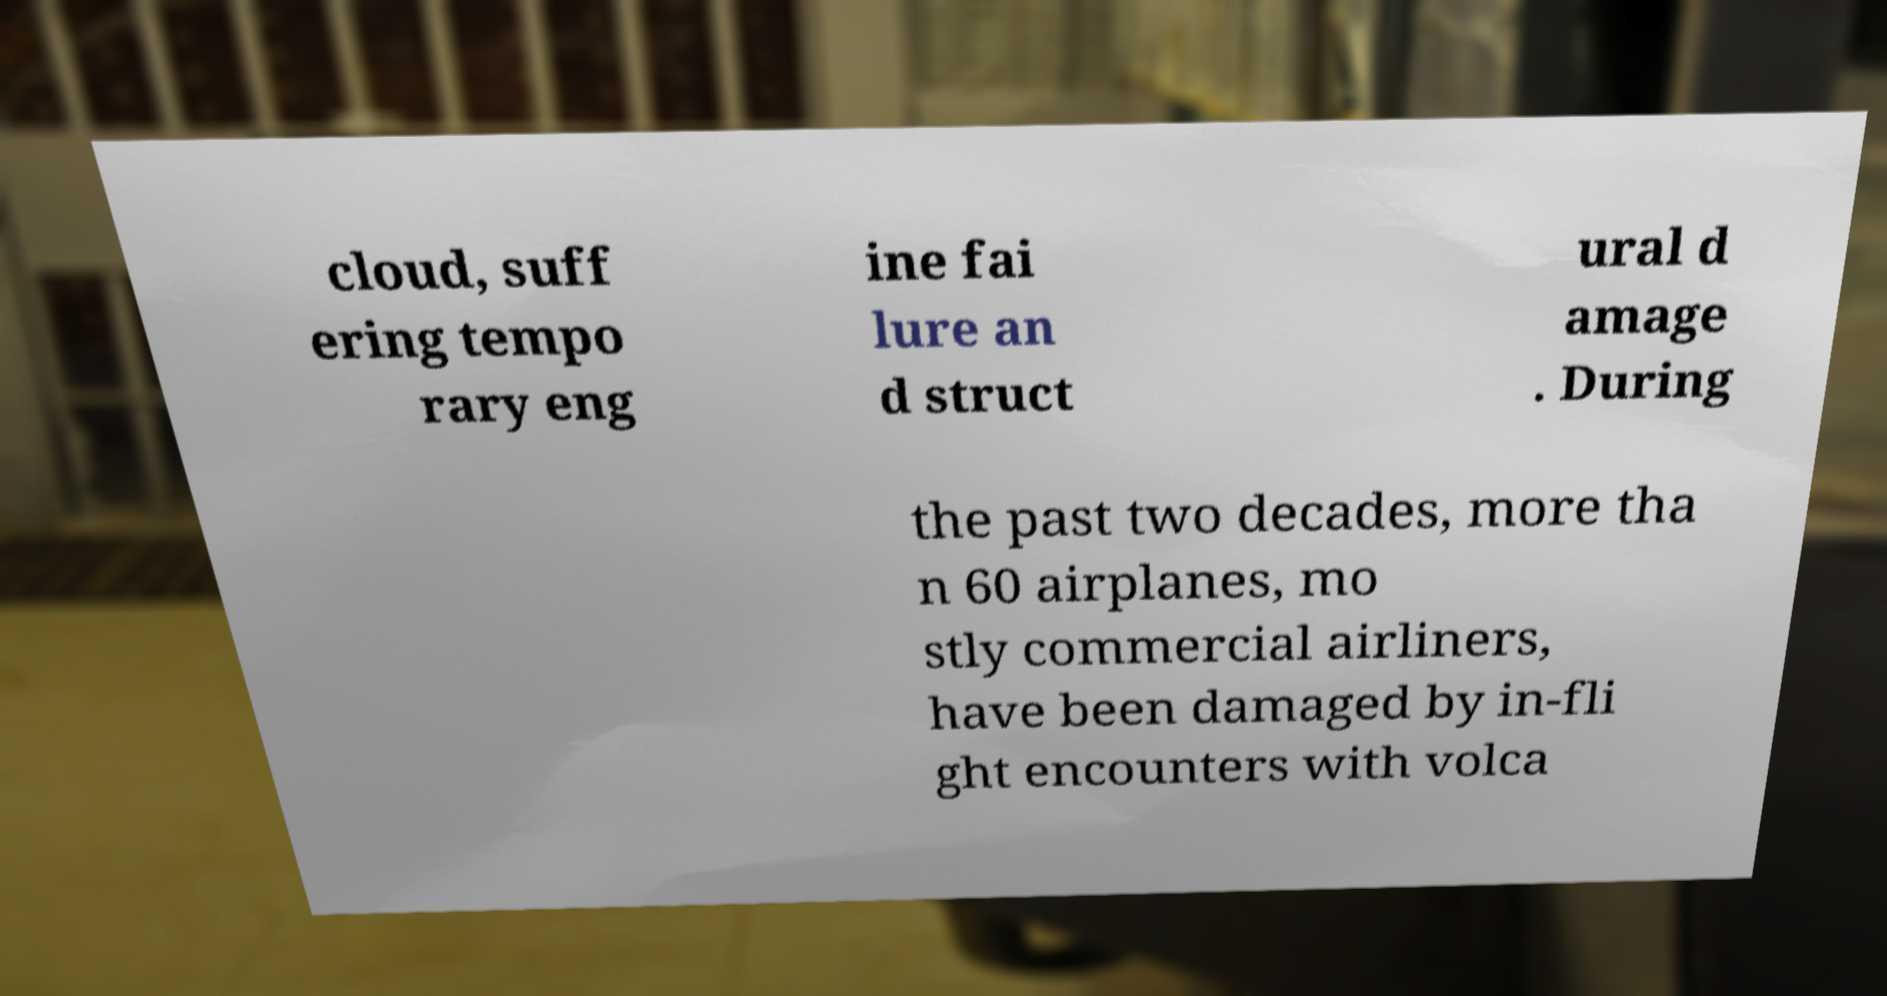There's text embedded in this image that I need extracted. Can you transcribe it verbatim? cloud, suff ering tempo rary eng ine fai lure an d struct ural d amage . During the past two decades, more tha n 60 airplanes, mo stly commercial airliners, have been damaged by in-fli ght encounters with volca 